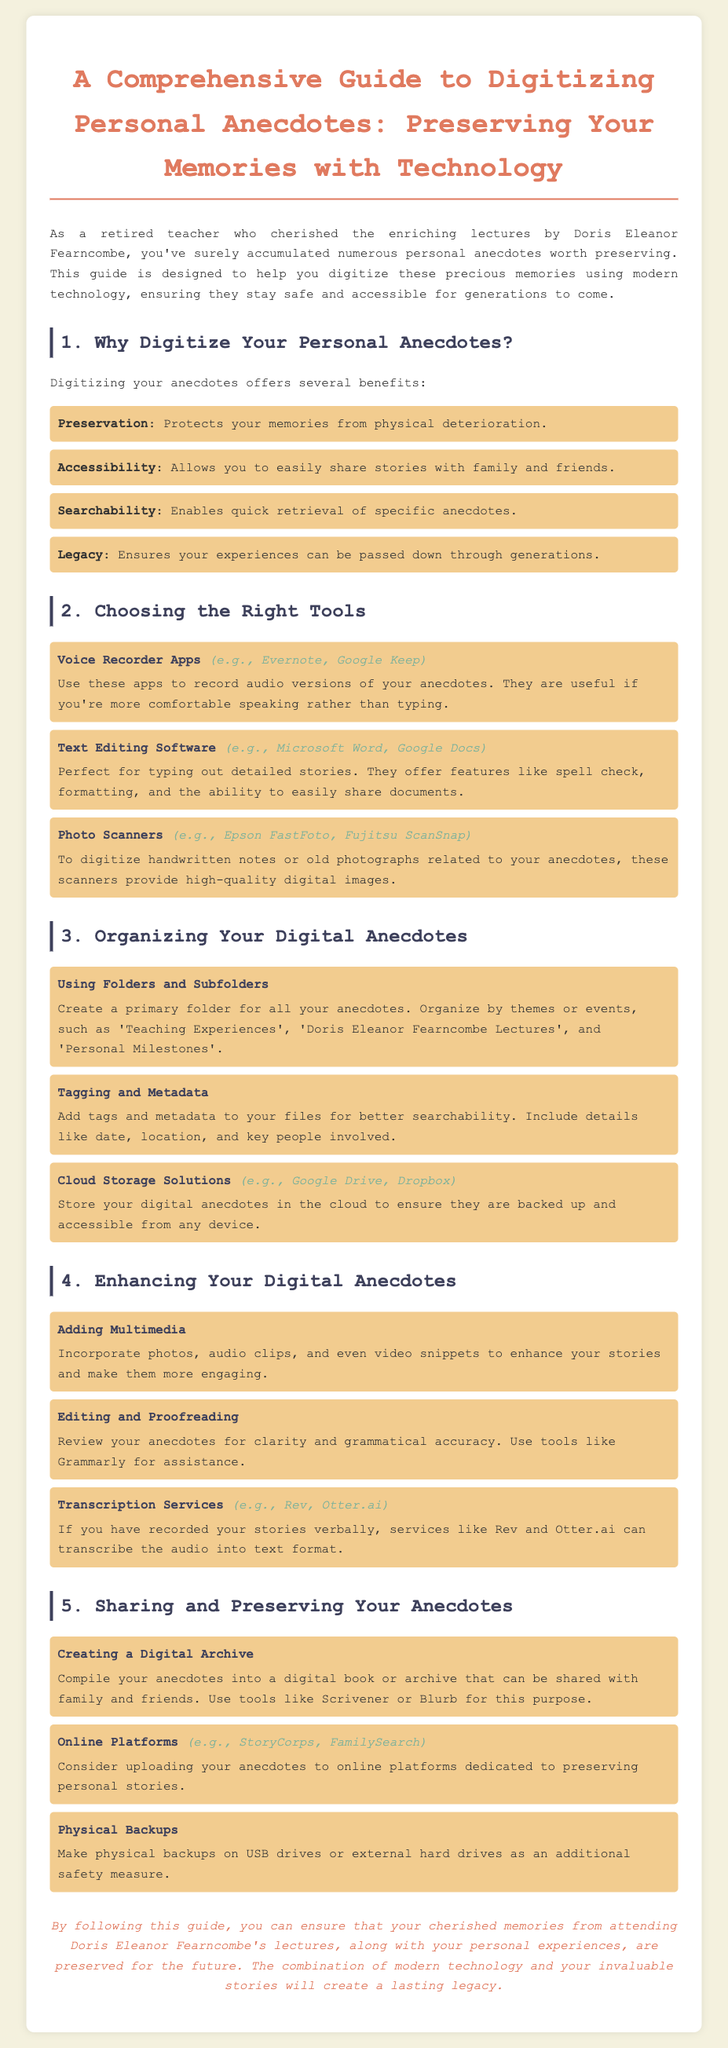What are the benefits of digitizing anecdotes? The benefits listed in the document include preservation, accessibility, searchability, and legacy.
Answer: Preservation, accessibility, searchability, legacy What tool is suggested for recording audio anecdotes? The document suggests using voice recorder apps for recording audio anecdotes.
Answer: Voice Recorder Apps Which software is recommended for typing out detailed stories? Microsoft Word and Google Docs are recommended for typing out detailed stories.
Answer: Microsoft Word, Google Docs What should you create to organize your digital anecdotes? The document recommends using folders and subfolders to organize your digital anecdotes.
Answer: Folders and subfolders Which service can help transcribe recorded stories? The document lists Rev and Otter.ai as transcription services for recorded stories.
Answer: Rev, Otter.ai What type of storage is recommended for backups? The document mentions making physical backups on USB drives or external hard drives.
Answer: USB drives, external hard drives What method involves compiling anecdotes into a digital archive? Creating a digital archive is recommended for compiling anecdotes to share with others.
Answer: Creating a digital archive Which online platforms are suggested for preserving personal stories? StoryCorps and FamilySearch are suggested as online platforms for preserving personal stories.
Answer: StoryCorps, FamilySearch 